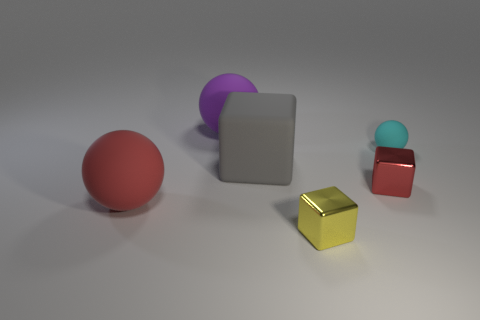What number of objects are small green metallic blocks or cyan objects?
Offer a terse response. 1. The purple matte object that is the same shape as the cyan matte object is what size?
Provide a short and direct response. Large. What number of spheres are either big red rubber objects or tiny cyan objects?
Provide a short and direct response. 2. What color is the large ball in front of the big object that is right of the purple rubber sphere?
Keep it short and to the point. Red. What shape is the large purple matte thing?
Offer a terse response. Sphere. Do the rubber thing that is right of the gray cube and the red shiny thing have the same size?
Provide a short and direct response. Yes. Are there any other objects that have the same material as the small yellow thing?
Keep it short and to the point. Yes. How many objects are tiny things in front of the tiny cyan object or large things?
Provide a succinct answer. 5. Is there a tiny cyan object?
Keep it short and to the point. Yes. What is the shape of the tiny thing that is both behind the small yellow shiny thing and to the left of the tiny cyan rubber object?
Offer a terse response. Cube. 